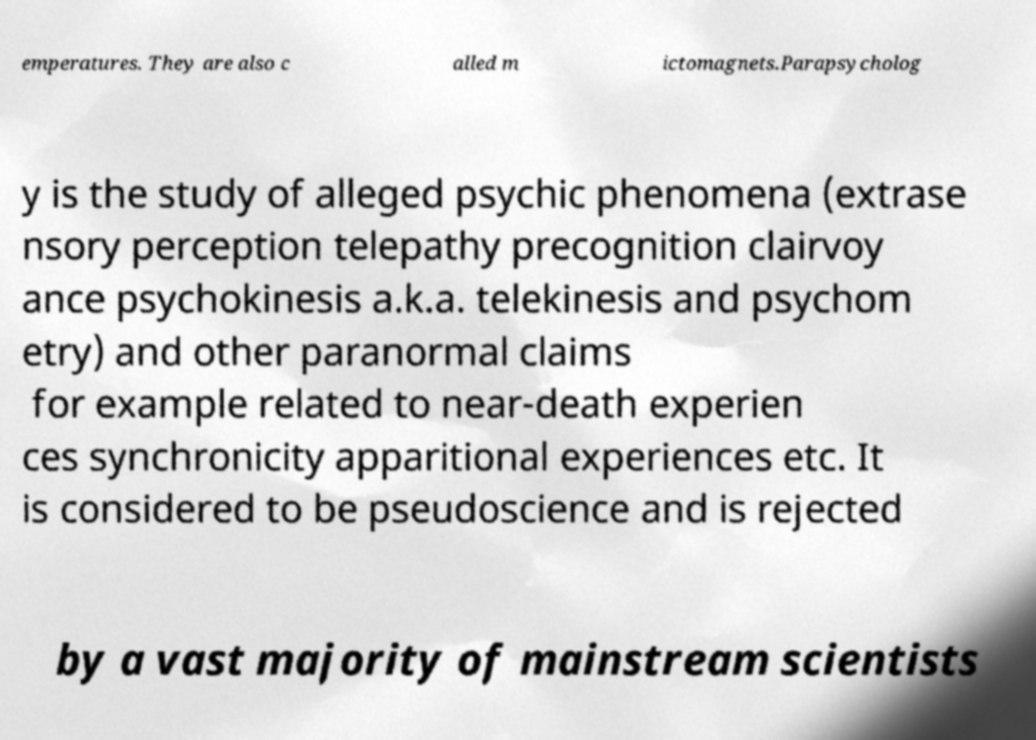Can you accurately transcribe the text from the provided image for me? emperatures. They are also c alled m ictomagnets.Parapsycholog y is the study of alleged psychic phenomena (extrase nsory perception telepathy precognition clairvoy ance psychokinesis a.k.a. telekinesis and psychom etry) and other paranormal claims for example related to near-death experien ces synchronicity apparitional experiences etc. It is considered to be pseudoscience and is rejected by a vast majority of mainstream scientists 